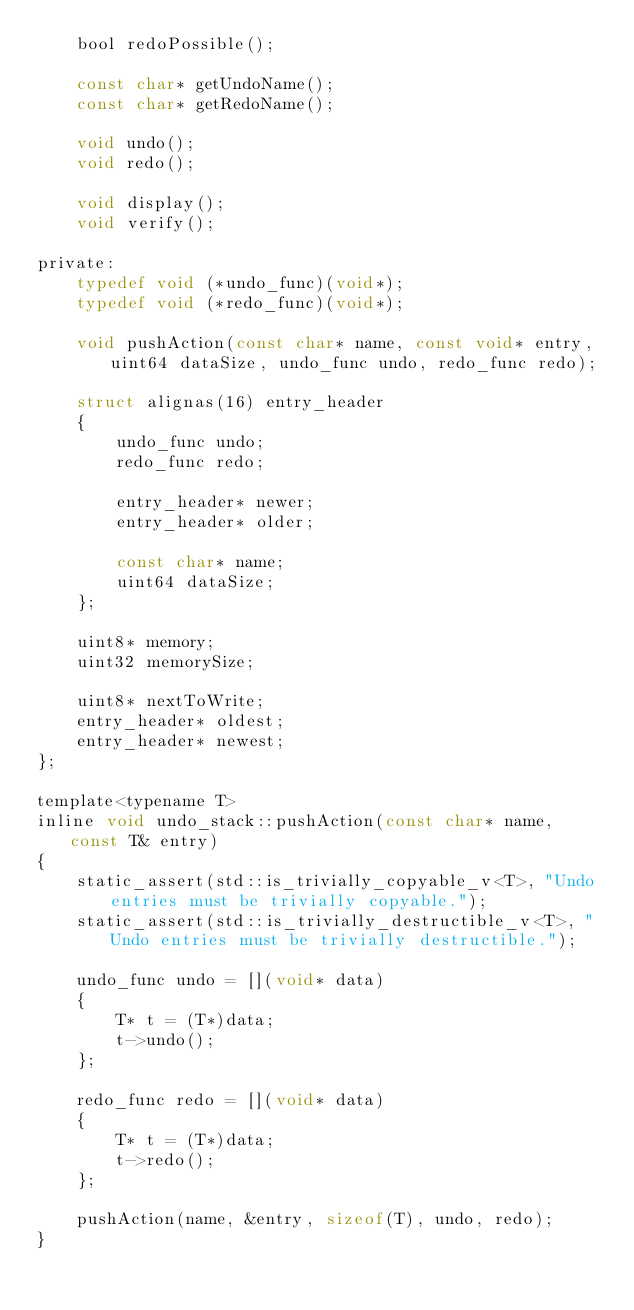Convert code to text. <code><loc_0><loc_0><loc_500><loc_500><_C_>	bool redoPossible();

	const char* getUndoName();
	const char* getRedoName();

	void undo();
	void redo();

	void display();
	void verify();

private:
	typedef void (*undo_func)(void*);
	typedef void (*redo_func)(void*);

	void pushAction(const char* name, const void* entry, uint64 dataSize, undo_func undo, redo_func redo);

	struct alignas(16) entry_header
	{
		undo_func undo;
		redo_func redo;

		entry_header* newer;
		entry_header* older;

		const char* name;
		uint64 dataSize;
	};

	uint8* memory;
	uint32 memorySize;

	uint8* nextToWrite;
	entry_header* oldest;
	entry_header* newest;
};

template<typename T>
inline void undo_stack::pushAction(const char* name, const T& entry)
{
	static_assert(std::is_trivially_copyable_v<T>, "Undo entries must be trivially copyable.");
	static_assert(std::is_trivially_destructible_v<T>, "Undo entries must be trivially destructible.");

	undo_func undo = [](void* data)
	{
		T* t = (T*)data;
		t->undo();
	};

	redo_func redo = [](void* data)
	{
		T* t = (T*)data;
		t->redo();
	};

	pushAction(name, &entry, sizeof(T), undo, redo);
}
</code> 